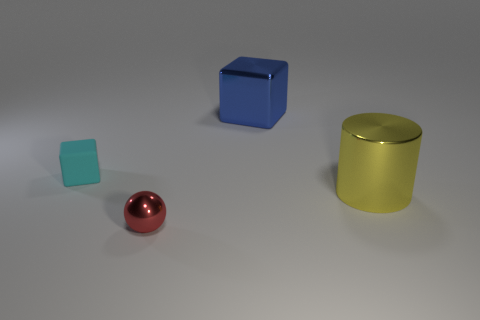What number of large yellow balls are there?
Your response must be concise. 0. What number of small objects are either blue objects or cyan balls?
Make the answer very short. 0. The yellow thing that is the same size as the metallic block is what shape?
Your answer should be very brief. Cylinder. Is there any other thing that is the same size as the red shiny object?
Ensure brevity in your answer.  Yes. The thing that is left of the tiny object that is in front of the large shiny cylinder is made of what material?
Provide a succinct answer. Rubber. Is the size of the yellow metal thing the same as the cyan rubber thing?
Provide a succinct answer. No. What number of things are either large objects that are on the right side of the blue metal cube or small purple blocks?
Keep it short and to the point. 1. There is a small thing that is behind the tiny thing on the right side of the cyan matte thing; what is its shape?
Your answer should be compact. Cube. Does the cyan rubber object have the same size as the object that is behind the tiny cyan rubber thing?
Ensure brevity in your answer.  No. What is the material of the small object that is behind the red sphere?
Ensure brevity in your answer.  Rubber. 